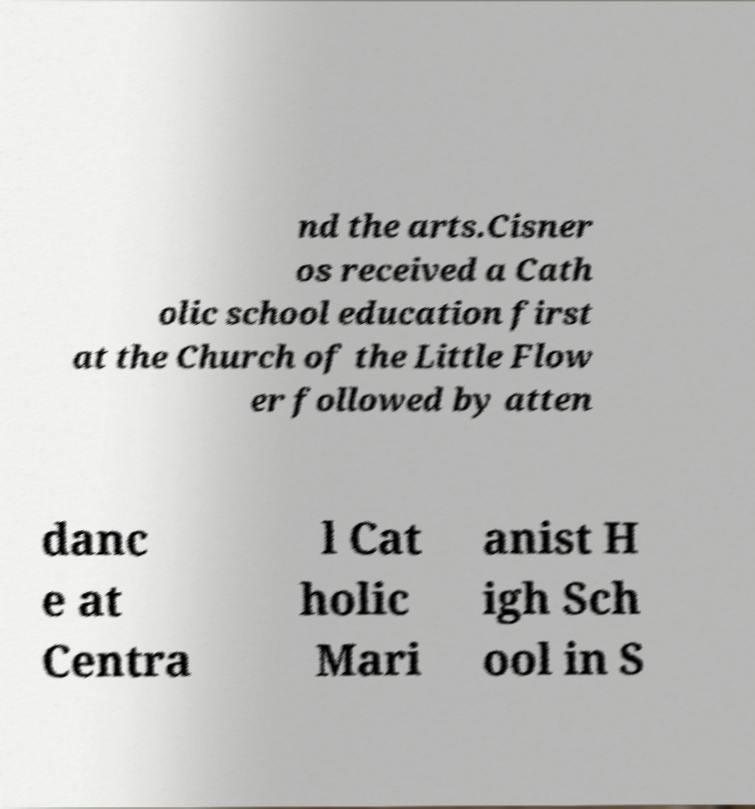Could you extract and type out the text from this image? nd the arts.Cisner os received a Cath olic school education first at the Church of the Little Flow er followed by atten danc e at Centra l Cat holic Mari anist H igh Sch ool in S 